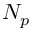Convert formula to latex. <formula><loc_0><loc_0><loc_500><loc_500>N _ { p }</formula> 